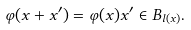Convert formula to latex. <formula><loc_0><loc_0><loc_500><loc_500>\varphi ( x + x ^ { \prime } ) = \varphi ( x ) x ^ { \prime } \in B _ { l ( x ) } .</formula> 